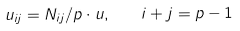Convert formula to latex. <formula><loc_0><loc_0><loc_500><loc_500>u _ { i j } = N _ { i j } / p \cdot u , \quad i + j = p - 1</formula> 